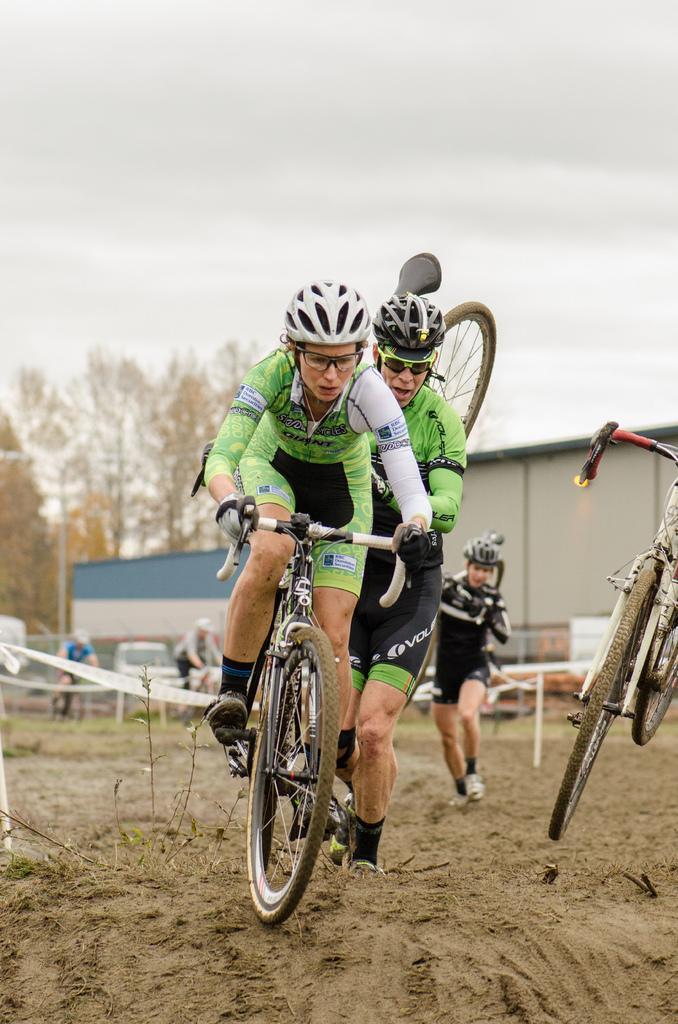In one or two sentences, can you explain what this image depicts? In this picture there is a woman who is wearing spectacles, helmet, t-shirt, shot, gloves and shoe. She is riding bicycle. Backside of her we can see a man who is holding the bicycle. On the right we can see a bicycle in the air. On the background we can see many vehicles near to the shed. On the left background we can see many trees. On the top we can see sky and clouds. 